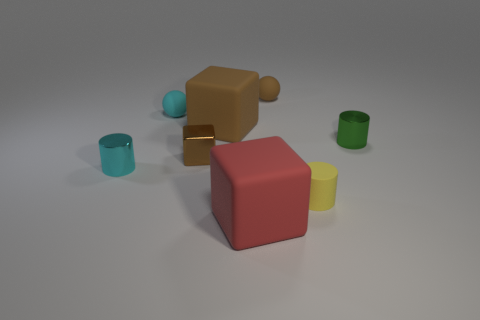Add 1 matte cylinders. How many objects exist? 9 Subtract all cylinders. How many objects are left? 5 Subtract 1 red cubes. How many objects are left? 7 Subtract all yellow rubber objects. Subtract all tiny red spheres. How many objects are left? 7 Add 1 cyan cylinders. How many cyan cylinders are left? 2 Add 4 big blue metallic spheres. How many big blue metallic spheres exist? 4 